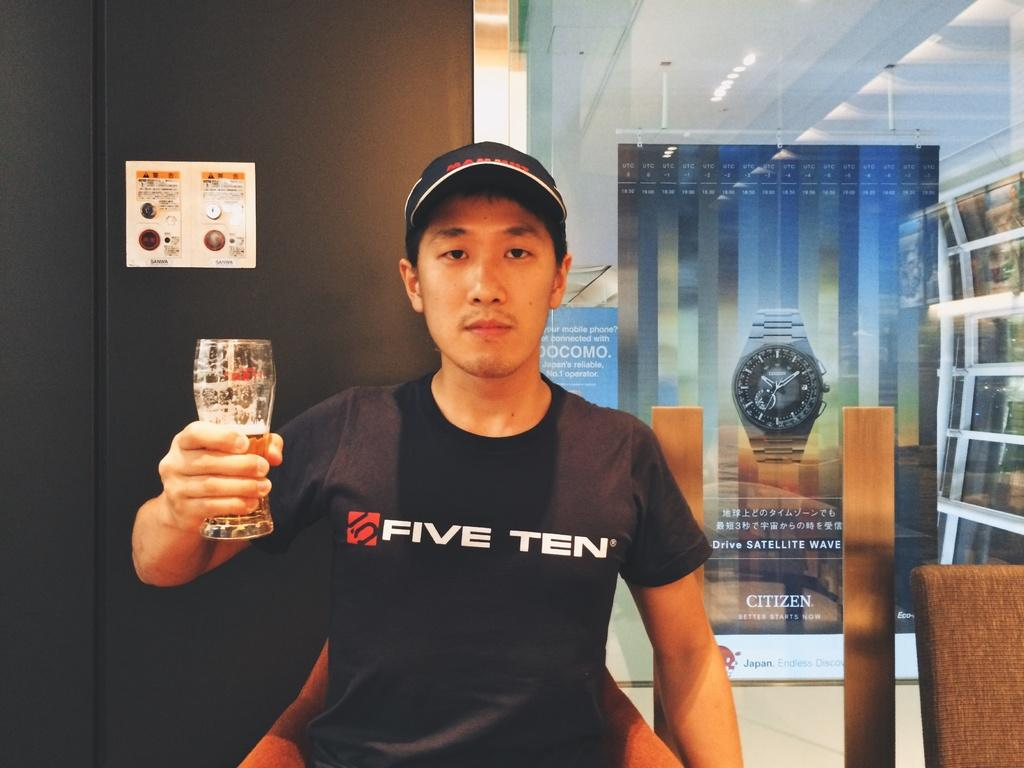Provide a one-sentence caption for the provided image. A man wearing a t-shirt with the word ten on it is holding a glass. 